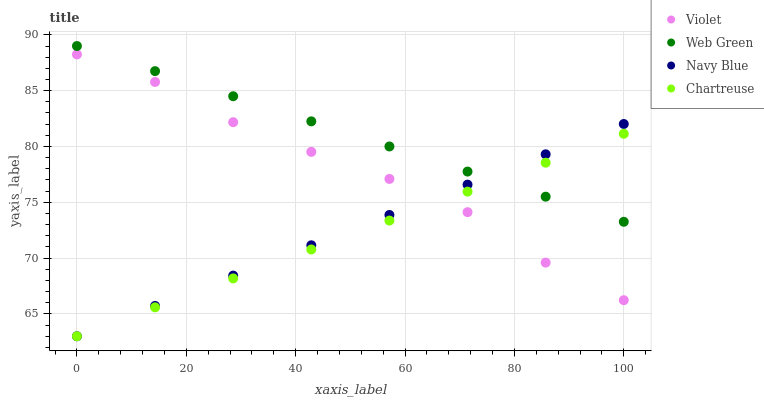Does Chartreuse have the minimum area under the curve?
Answer yes or no. Yes. Does Web Green have the maximum area under the curve?
Answer yes or no. Yes. Does Web Green have the minimum area under the curve?
Answer yes or no. No. Does Chartreuse have the maximum area under the curve?
Answer yes or no. No. Is Chartreuse the smoothest?
Answer yes or no. Yes. Is Violet the roughest?
Answer yes or no. Yes. Is Web Green the smoothest?
Answer yes or no. No. Is Web Green the roughest?
Answer yes or no. No. Does Navy Blue have the lowest value?
Answer yes or no. Yes. Does Web Green have the lowest value?
Answer yes or no. No. Does Web Green have the highest value?
Answer yes or no. Yes. Does Chartreuse have the highest value?
Answer yes or no. No. Is Violet less than Web Green?
Answer yes or no. Yes. Is Web Green greater than Violet?
Answer yes or no. Yes. Does Navy Blue intersect Web Green?
Answer yes or no. Yes. Is Navy Blue less than Web Green?
Answer yes or no. No. Is Navy Blue greater than Web Green?
Answer yes or no. No. Does Violet intersect Web Green?
Answer yes or no. No. 